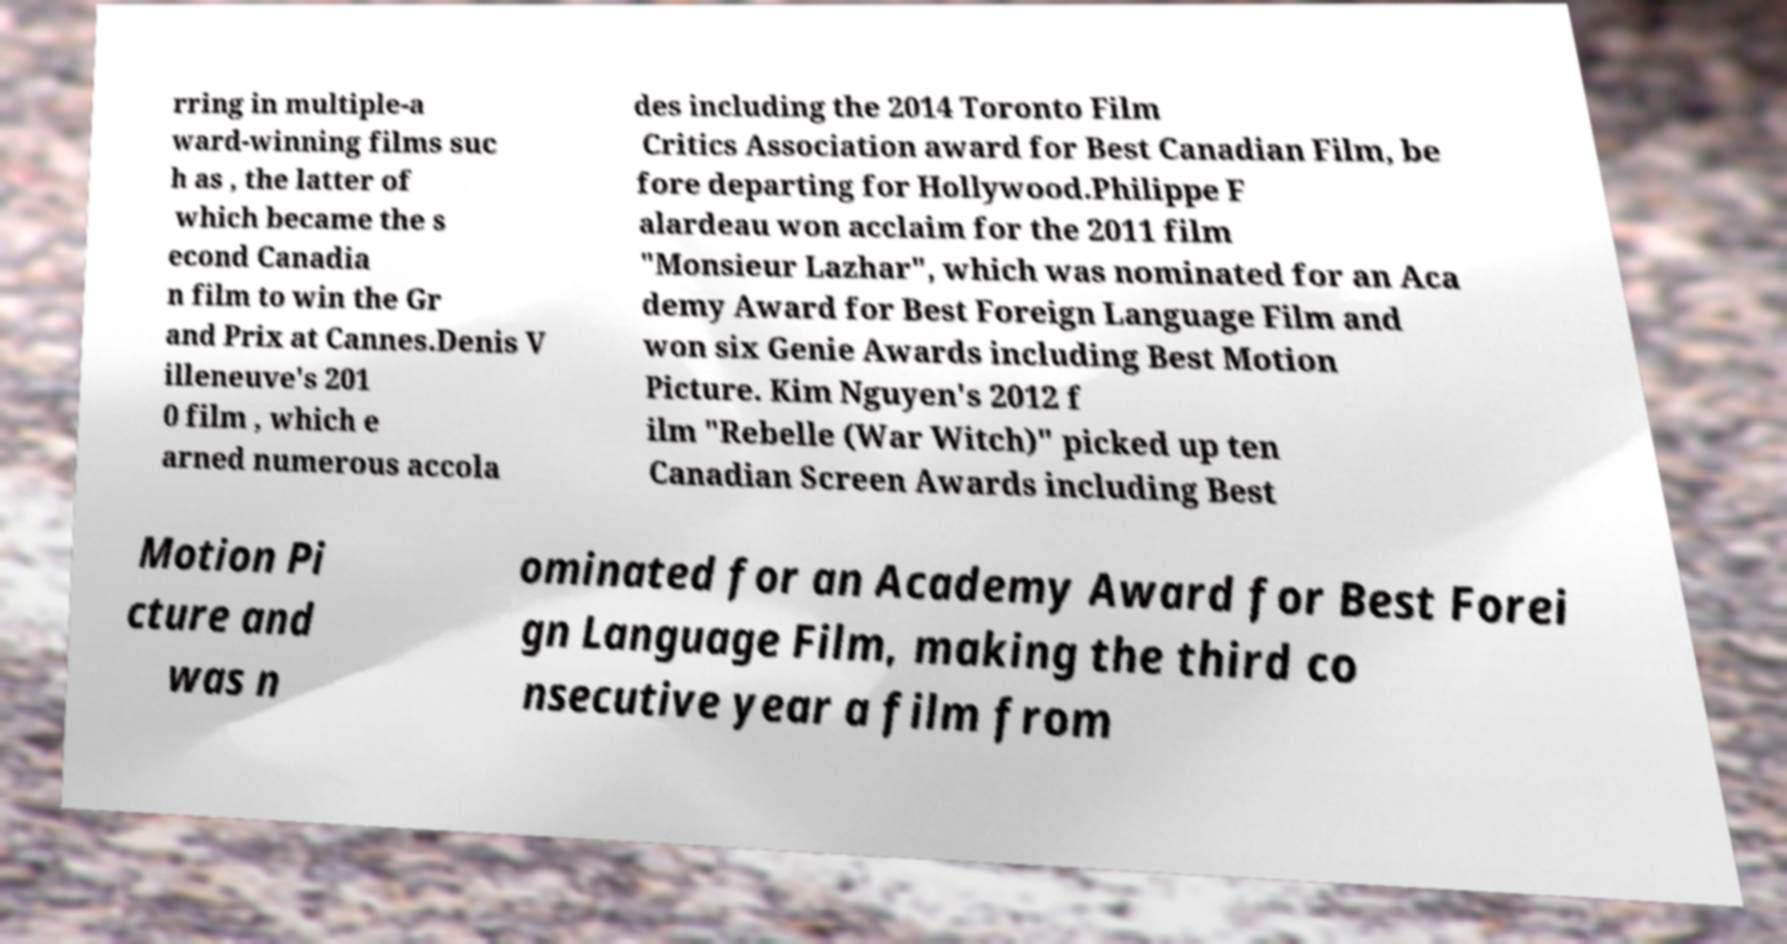What messages or text are displayed in this image? I need them in a readable, typed format. rring in multiple-a ward-winning films suc h as , the latter of which became the s econd Canadia n film to win the Gr and Prix at Cannes.Denis V illeneuve's 201 0 film , which e arned numerous accola des including the 2014 Toronto Film Critics Association award for Best Canadian Film, be fore departing for Hollywood.Philippe F alardeau won acclaim for the 2011 film "Monsieur Lazhar", which was nominated for an Aca demy Award for Best Foreign Language Film and won six Genie Awards including Best Motion Picture. Kim Nguyen's 2012 f ilm "Rebelle (War Witch)" picked up ten Canadian Screen Awards including Best Motion Pi cture and was n ominated for an Academy Award for Best Forei gn Language Film, making the third co nsecutive year a film from 